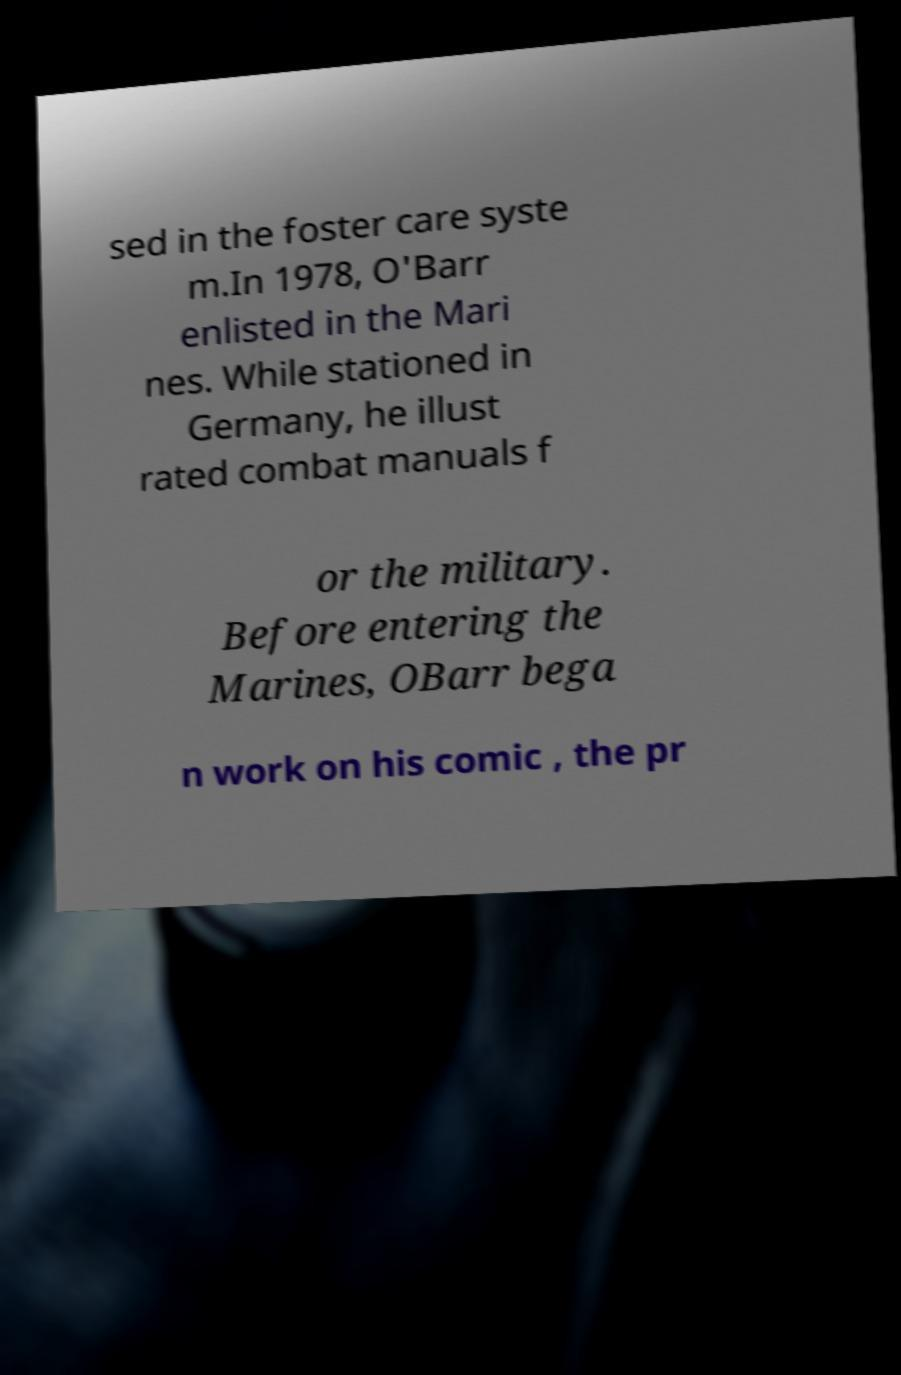Please read and relay the text visible in this image. What does it say? sed in the foster care syste m.In 1978, O'Barr enlisted in the Mari nes. While stationed in Germany, he illust rated combat manuals f or the military. Before entering the Marines, OBarr bega n work on his comic , the pr 